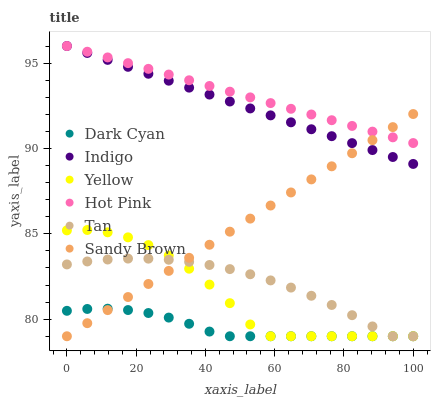Does Dark Cyan have the minimum area under the curve?
Answer yes or no. Yes. Does Hot Pink have the maximum area under the curve?
Answer yes or no. Yes. Does Yellow have the minimum area under the curve?
Answer yes or no. No. Does Yellow have the maximum area under the curve?
Answer yes or no. No. Is Sandy Brown the smoothest?
Answer yes or no. Yes. Is Yellow the roughest?
Answer yes or no. Yes. Is Hot Pink the smoothest?
Answer yes or no. No. Is Hot Pink the roughest?
Answer yes or no. No. Does Yellow have the lowest value?
Answer yes or no. Yes. Does Hot Pink have the lowest value?
Answer yes or no. No. Does Hot Pink have the highest value?
Answer yes or no. Yes. Does Yellow have the highest value?
Answer yes or no. No. Is Yellow less than Hot Pink?
Answer yes or no. Yes. Is Hot Pink greater than Yellow?
Answer yes or no. Yes. Does Dark Cyan intersect Tan?
Answer yes or no. Yes. Is Dark Cyan less than Tan?
Answer yes or no. No. Is Dark Cyan greater than Tan?
Answer yes or no. No. Does Yellow intersect Hot Pink?
Answer yes or no. No. 